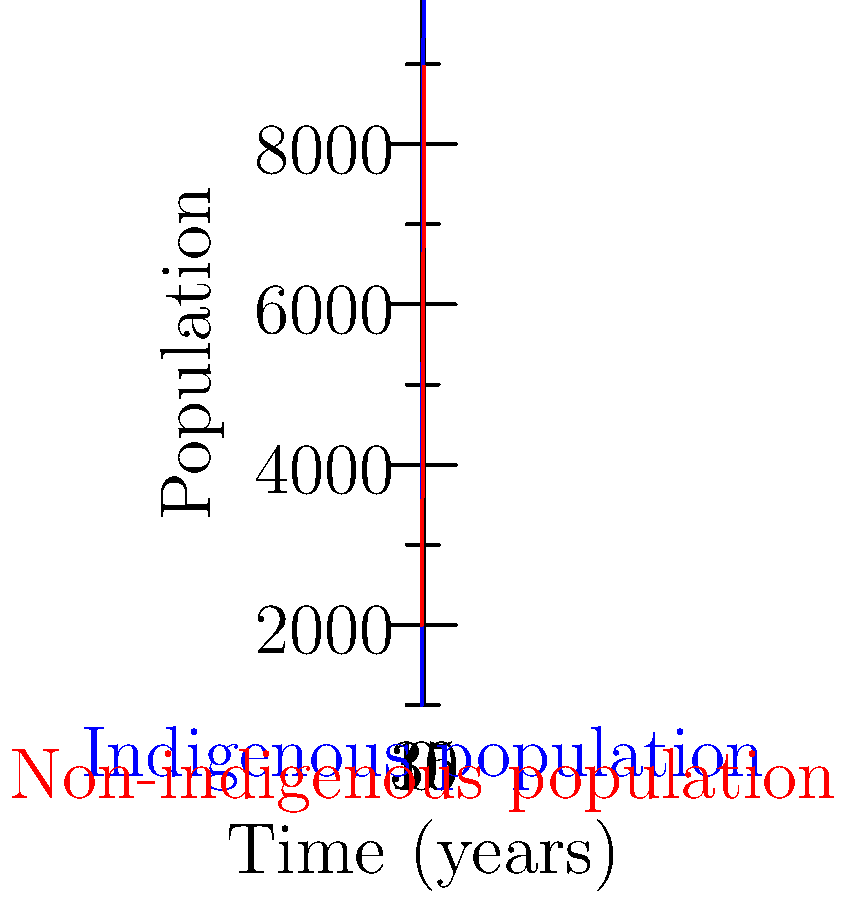The graph shows the growth of indigenous and non-indigenous populations in a region over time. The blue curve represents the indigenous population, which follows a logistic growth model, while the red curve represents the non-indigenous population, which follows exponential growth. At what point in time (to the nearest year) does the rate of change of the indigenous population growth reach its maximum? To find the point of maximum rate of change for the logistic growth curve (indigenous population), we need to follow these steps:

1) The logistic growth model is given by the equation:

   $$P(t) = \frac{K}{1 + ae^{-rt}}$$

   where $K$ is the carrying capacity, $a$ is a constant, $r$ is the growth rate, and $t$ is time.

2) From the graph, we can estimate that $K \approx 10000$ and the initial population $P(0) \approx 1000$.

3) The inflection point of a logistic curve occurs at half the carrying capacity, which is where the rate of change is maximum. So, we're looking for the time when $P(t) = 5000$.

4) We can set up the equation:

   $$5000 = \frac{10000}{1 + ae^{-rt}}$$

5) Solving for $t$:

   $$1 + ae^{-rt} = 2$$
   $$ae^{-rt} = 1$$
   $$-rt = \ln(\frac{1}{a})$$
   $$t = -\frac{1}{r}\ln(\frac{1}{a})$$

6) To find $a$, we can use the initial condition:

   $$1000 = \frac{10000}{1 + a}$$
   $$a = 9$$

7) To find $r$, we can estimate from the graph that it takes about 15 years for the population to reach 5000. So:

   $$15 = -\frac{1}{r}\ln(\frac{1}{9})$$
   $$r \approx 0.2$$

8) Therefore, the time of maximum rate of change is:

   $$t = -\frac{1}{0.2}\ln(\frac{1}{9}) \approx 11.0$$

Rounding to the nearest year, we get 11 years.
Answer: 11 years 